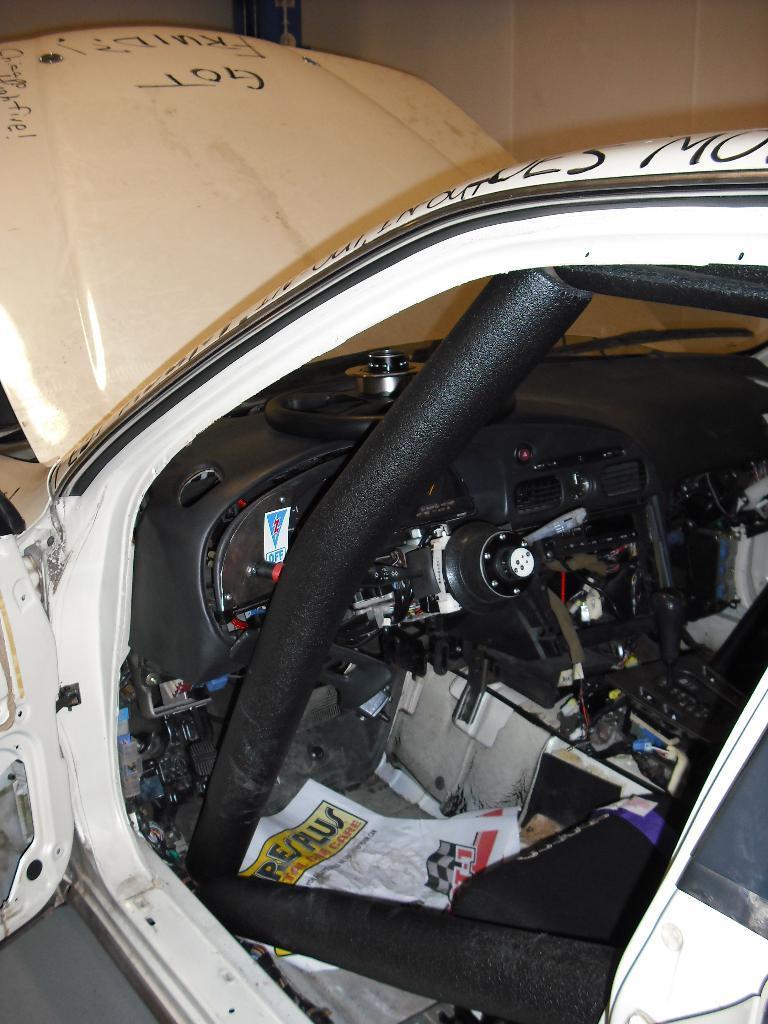How would you summarize this image in a sentence or two? In this image, I can see a car, which is white in color. This is a bonnet, which is attached to the car. I can see few devices, which are fixed inside the car. This looks like a seat. I can see the letters written on the car. 